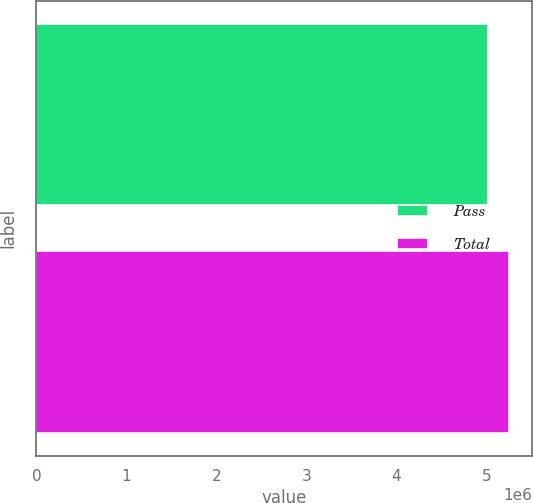Convert chart to OTSL. <chart><loc_0><loc_0><loc_500><loc_500><bar_chart><fcel>Pass<fcel>Total<nl><fcel>5.01279e+06<fcel>5.246e+06<nl></chart> 